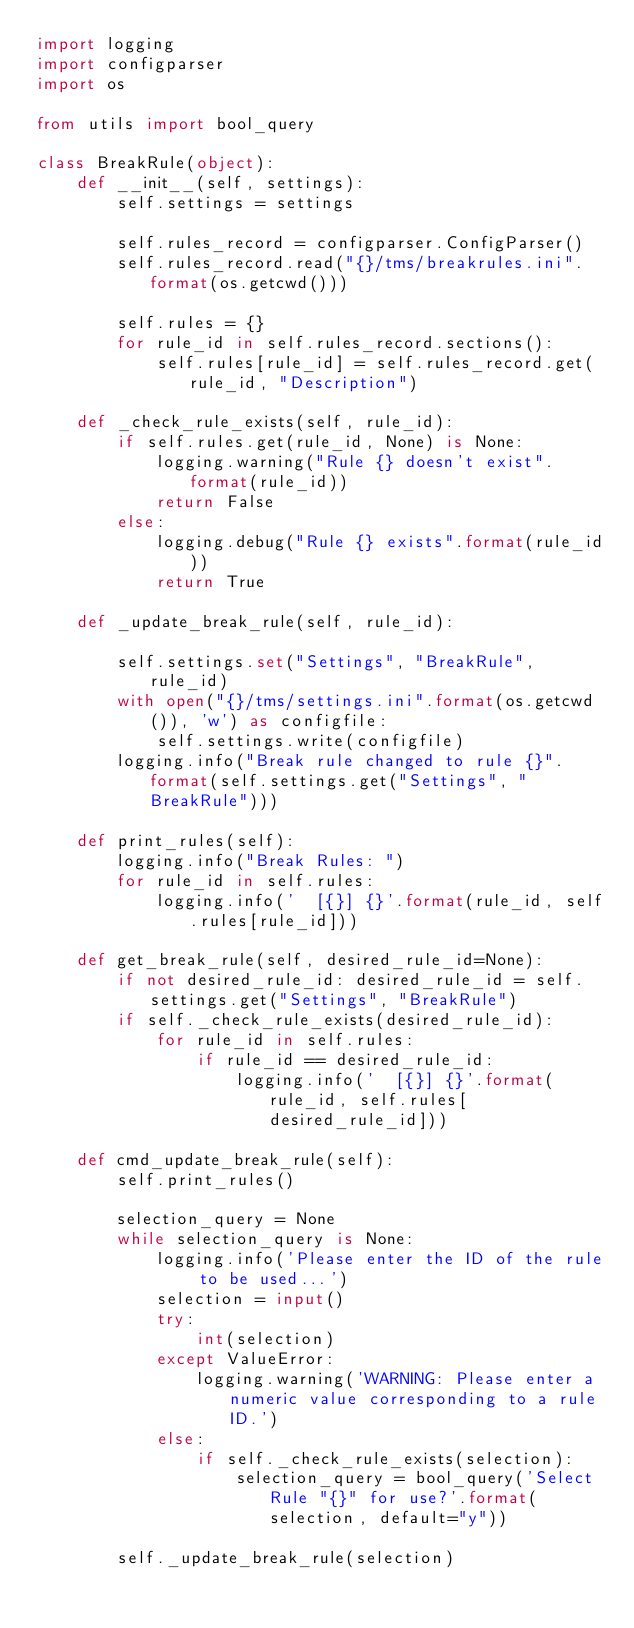Convert code to text. <code><loc_0><loc_0><loc_500><loc_500><_Python_>import logging
import configparser
import os

from utils import bool_query

class BreakRule(object):
    def __init__(self, settings):
        self.settings = settings

        self.rules_record = configparser.ConfigParser()
        self.rules_record.read("{}/tms/breakrules.ini".format(os.getcwd()))

        self.rules = {}
        for rule_id in self.rules_record.sections():
            self.rules[rule_id] = self.rules_record.get(rule_id, "Description")

    def _check_rule_exists(self, rule_id):
        if self.rules.get(rule_id, None) is None:
            logging.warning("Rule {} doesn't exist".format(rule_id))
            return False
        else:
            logging.debug("Rule {} exists".format(rule_id))
            return True
    
    def _update_break_rule(self, rule_id):

        self.settings.set("Settings", "BreakRule", rule_id)
        with open("{}/tms/settings.ini".format(os.getcwd()), 'w') as configfile:
            self.settings.write(configfile)
        logging.info("Break rule changed to rule {}".format(self.settings.get("Settings", "BreakRule")))

    def print_rules(self):
        logging.info("Break Rules: ")
        for rule_id in self.rules:
            logging.info('  [{}] {}'.format(rule_id, self.rules[rule_id]))

    def get_break_rule(self, desired_rule_id=None):
        if not desired_rule_id: desired_rule_id = self.settings.get("Settings", "BreakRule")
        if self._check_rule_exists(desired_rule_id):
            for rule_id in self.rules:
                if rule_id == desired_rule_id:
                    logging.info('  [{}] {}'.format(rule_id, self.rules[desired_rule_id]))

    def cmd_update_break_rule(self):
        self.print_rules()

        selection_query = None
        while selection_query is None:
            logging.info('Please enter the ID of the rule to be used...')
            selection = input()
            try:
                int(selection)
            except ValueError:
                logging.warning('WARNING: Please enter a numeric value corresponding to a rule ID.')
            else:
                if self._check_rule_exists(selection):
                    selection_query = bool_query('Select Rule "{}" for use?'.format(selection, default="y"))
        
        self._update_break_rule(selection)
</code> 